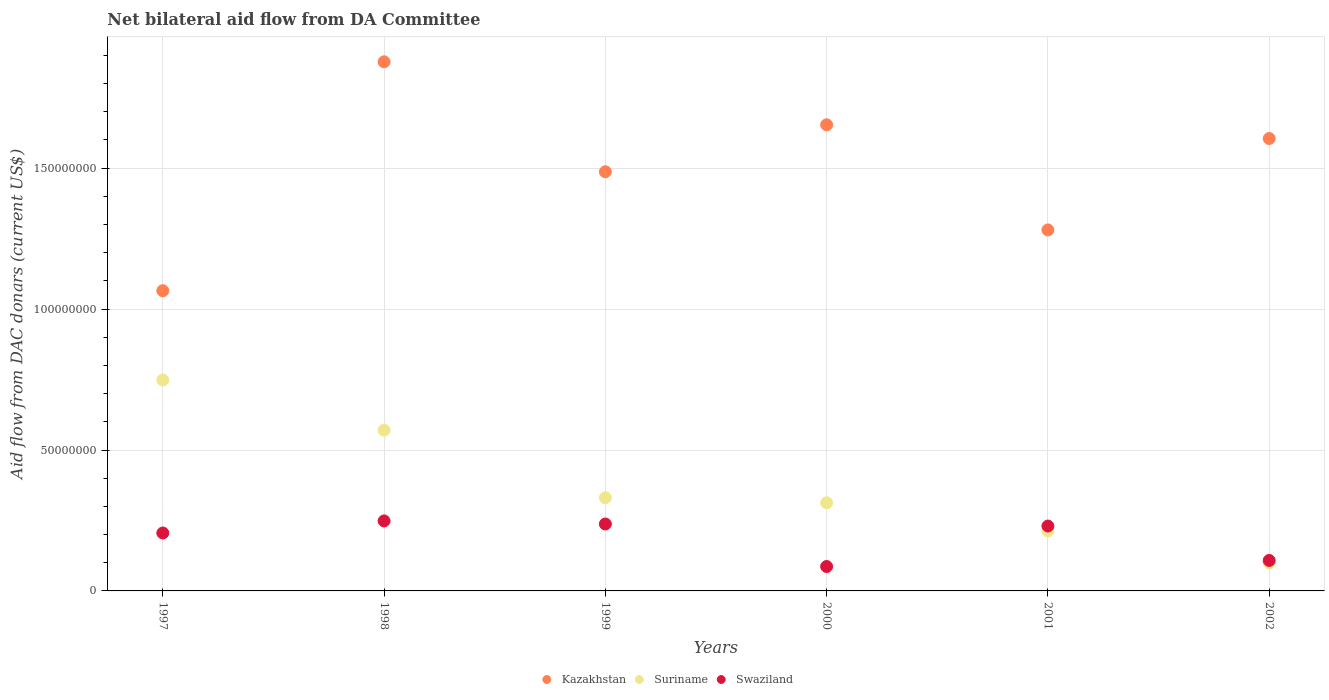How many different coloured dotlines are there?
Offer a terse response. 3. Is the number of dotlines equal to the number of legend labels?
Your answer should be very brief. Yes. What is the aid flow in in Suriname in 2002?
Keep it short and to the point. 9.96e+06. Across all years, what is the maximum aid flow in in Swaziland?
Offer a very short reply. 2.48e+07. Across all years, what is the minimum aid flow in in Swaziland?
Give a very brief answer. 8.66e+06. What is the total aid flow in in Swaziland in the graph?
Provide a short and direct response. 1.12e+08. What is the difference between the aid flow in in Suriname in 1997 and that in 2002?
Keep it short and to the point. 6.49e+07. What is the difference between the aid flow in in Kazakhstan in 1998 and the aid flow in in Suriname in 1999?
Offer a terse response. 1.55e+08. What is the average aid flow in in Suriname per year?
Your answer should be compact. 3.79e+07. In the year 2001, what is the difference between the aid flow in in Swaziland and aid flow in in Kazakhstan?
Keep it short and to the point. -1.05e+08. What is the ratio of the aid flow in in Kazakhstan in 1999 to that in 2000?
Give a very brief answer. 0.9. What is the difference between the highest and the second highest aid flow in in Suriname?
Offer a terse response. 1.78e+07. What is the difference between the highest and the lowest aid flow in in Suriname?
Offer a terse response. 6.49e+07. In how many years, is the aid flow in in Suriname greater than the average aid flow in in Suriname taken over all years?
Make the answer very short. 2. Is it the case that in every year, the sum of the aid flow in in Swaziland and aid flow in in Kazakhstan  is greater than the aid flow in in Suriname?
Keep it short and to the point. Yes. Does the aid flow in in Swaziland monotonically increase over the years?
Ensure brevity in your answer.  No. How many dotlines are there?
Ensure brevity in your answer.  3. Does the graph contain grids?
Your answer should be very brief. Yes. How many legend labels are there?
Provide a short and direct response. 3. How are the legend labels stacked?
Your answer should be very brief. Horizontal. What is the title of the graph?
Provide a short and direct response. Net bilateral aid flow from DA Committee. What is the label or title of the Y-axis?
Provide a succinct answer. Aid flow from DAC donars (current US$). What is the Aid flow from DAC donars (current US$) in Kazakhstan in 1997?
Keep it short and to the point. 1.07e+08. What is the Aid flow from DAC donars (current US$) in Suriname in 1997?
Keep it short and to the point. 7.48e+07. What is the Aid flow from DAC donars (current US$) of Swaziland in 1997?
Your answer should be compact. 2.06e+07. What is the Aid flow from DAC donars (current US$) of Kazakhstan in 1998?
Keep it short and to the point. 1.88e+08. What is the Aid flow from DAC donars (current US$) of Suriname in 1998?
Make the answer very short. 5.70e+07. What is the Aid flow from DAC donars (current US$) of Swaziland in 1998?
Provide a short and direct response. 2.48e+07. What is the Aid flow from DAC donars (current US$) of Kazakhstan in 1999?
Offer a terse response. 1.49e+08. What is the Aid flow from DAC donars (current US$) of Suriname in 1999?
Offer a very short reply. 3.31e+07. What is the Aid flow from DAC donars (current US$) in Swaziland in 1999?
Keep it short and to the point. 2.37e+07. What is the Aid flow from DAC donars (current US$) in Kazakhstan in 2000?
Your answer should be very brief. 1.65e+08. What is the Aid flow from DAC donars (current US$) in Suriname in 2000?
Provide a short and direct response. 3.13e+07. What is the Aid flow from DAC donars (current US$) of Swaziland in 2000?
Make the answer very short. 8.66e+06. What is the Aid flow from DAC donars (current US$) in Kazakhstan in 2001?
Offer a very short reply. 1.28e+08. What is the Aid flow from DAC donars (current US$) in Suriname in 2001?
Keep it short and to the point. 2.13e+07. What is the Aid flow from DAC donars (current US$) in Swaziland in 2001?
Provide a succinct answer. 2.30e+07. What is the Aid flow from DAC donars (current US$) in Kazakhstan in 2002?
Give a very brief answer. 1.61e+08. What is the Aid flow from DAC donars (current US$) in Suriname in 2002?
Make the answer very short. 9.96e+06. What is the Aid flow from DAC donars (current US$) in Swaziland in 2002?
Offer a terse response. 1.08e+07. Across all years, what is the maximum Aid flow from DAC donars (current US$) in Kazakhstan?
Make the answer very short. 1.88e+08. Across all years, what is the maximum Aid flow from DAC donars (current US$) of Suriname?
Keep it short and to the point. 7.48e+07. Across all years, what is the maximum Aid flow from DAC donars (current US$) of Swaziland?
Ensure brevity in your answer.  2.48e+07. Across all years, what is the minimum Aid flow from DAC donars (current US$) of Kazakhstan?
Your answer should be compact. 1.07e+08. Across all years, what is the minimum Aid flow from DAC donars (current US$) of Suriname?
Ensure brevity in your answer.  9.96e+06. Across all years, what is the minimum Aid flow from DAC donars (current US$) of Swaziland?
Provide a succinct answer. 8.66e+06. What is the total Aid flow from DAC donars (current US$) in Kazakhstan in the graph?
Provide a short and direct response. 8.97e+08. What is the total Aid flow from DAC donars (current US$) of Suriname in the graph?
Your response must be concise. 2.28e+08. What is the total Aid flow from DAC donars (current US$) of Swaziland in the graph?
Ensure brevity in your answer.  1.12e+08. What is the difference between the Aid flow from DAC donars (current US$) in Kazakhstan in 1997 and that in 1998?
Offer a very short reply. -8.12e+07. What is the difference between the Aid flow from DAC donars (current US$) in Suriname in 1997 and that in 1998?
Your response must be concise. 1.78e+07. What is the difference between the Aid flow from DAC donars (current US$) of Swaziland in 1997 and that in 1998?
Give a very brief answer. -4.29e+06. What is the difference between the Aid flow from DAC donars (current US$) of Kazakhstan in 1997 and that in 1999?
Provide a short and direct response. -4.22e+07. What is the difference between the Aid flow from DAC donars (current US$) of Suriname in 1997 and that in 1999?
Your answer should be very brief. 4.18e+07. What is the difference between the Aid flow from DAC donars (current US$) of Swaziland in 1997 and that in 1999?
Ensure brevity in your answer.  -3.19e+06. What is the difference between the Aid flow from DAC donars (current US$) of Kazakhstan in 1997 and that in 2000?
Offer a terse response. -5.89e+07. What is the difference between the Aid flow from DAC donars (current US$) in Suriname in 1997 and that in 2000?
Make the answer very short. 4.36e+07. What is the difference between the Aid flow from DAC donars (current US$) in Swaziland in 1997 and that in 2000?
Give a very brief answer. 1.19e+07. What is the difference between the Aid flow from DAC donars (current US$) in Kazakhstan in 1997 and that in 2001?
Give a very brief answer. -2.16e+07. What is the difference between the Aid flow from DAC donars (current US$) in Suriname in 1997 and that in 2001?
Offer a very short reply. 5.36e+07. What is the difference between the Aid flow from DAC donars (current US$) in Swaziland in 1997 and that in 2001?
Ensure brevity in your answer.  -2.47e+06. What is the difference between the Aid flow from DAC donars (current US$) of Kazakhstan in 1997 and that in 2002?
Make the answer very short. -5.40e+07. What is the difference between the Aid flow from DAC donars (current US$) in Suriname in 1997 and that in 2002?
Ensure brevity in your answer.  6.49e+07. What is the difference between the Aid flow from DAC donars (current US$) of Swaziland in 1997 and that in 2002?
Give a very brief answer. 9.74e+06. What is the difference between the Aid flow from DAC donars (current US$) in Kazakhstan in 1998 and that in 1999?
Keep it short and to the point. 3.90e+07. What is the difference between the Aid flow from DAC donars (current US$) of Suriname in 1998 and that in 1999?
Provide a succinct answer. 2.40e+07. What is the difference between the Aid flow from DAC donars (current US$) in Swaziland in 1998 and that in 1999?
Your response must be concise. 1.10e+06. What is the difference between the Aid flow from DAC donars (current US$) in Kazakhstan in 1998 and that in 2000?
Make the answer very short. 2.23e+07. What is the difference between the Aid flow from DAC donars (current US$) in Suriname in 1998 and that in 2000?
Your response must be concise. 2.58e+07. What is the difference between the Aid flow from DAC donars (current US$) of Swaziland in 1998 and that in 2000?
Offer a very short reply. 1.62e+07. What is the difference between the Aid flow from DAC donars (current US$) in Kazakhstan in 1998 and that in 2001?
Provide a short and direct response. 5.96e+07. What is the difference between the Aid flow from DAC donars (current US$) in Suriname in 1998 and that in 2001?
Provide a succinct answer. 3.58e+07. What is the difference between the Aid flow from DAC donars (current US$) of Swaziland in 1998 and that in 2001?
Your answer should be compact. 1.82e+06. What is the difference between the Aid flow from DAC donars (current US$) in Kazakhstan in 1998 and that in 2002?
Ensure brevity in your answer.  2.72e+07. What is the difference between the Aid flow from DAC donars (current US$) in Suriname in 1998 and that in 2002?
Provide a succinct answer. 4.71e+07. What is the difference between the Aid flow from DAC donars (current US$) in Swaziland in 1998 and that in 2002?
Provide a succinct answer. 1.40e+07. What is the difference between the Aid flow from DAC donars (current US$) in Kazakhstan in 1999 and that in 2000?
Your answer should be very brief. -1.67e+07. What is the difference between the Aid flow from DAC donars (current US$) in Suriname in 1999 and that in 2000?
Ensure brevity in your answer.  1.77e+06. What is the difference between the Aid flow from DAC donars (current US$) of Swaziland in 1999 and that in 2000?
Offer a terse response. 1.51e+07. What is the difference between the Aid flow from DAC donars (current US$) of Kazakhstan in 1999 and that in 2001?
Keep it short and to the point. 2.06e+07. What is the difference between the Aid flow from DAC donars (current US$) in Suriname in 1999 and that in 2001?
Offer a very short reply. 1.18e+07. What is the difference between the Aid flow from DAC donars (current US$) of Swaziland in 1999 and that in 2001?
Keep it short and to the point. 7.20e+05. What is the difference between the Aid flow from DAC donars (current US$) in Kazakhstan in 1999 and that in 2002?
Ensure brevity in your answer.  -1.18e+07. What is the difference between the Aid flow from DAC donars (current US$) in Suriname in 1999 and that in 2002?
Give a very brief answer. 2.31e+07. What is the difference between the Aid flow from DAC donars (current US$) of Swaziland in 1999 and that in 2002?
Your response must be concise. 1.29e+07. What is the difference between the Aid flow from DAC donars (current US$) of Kazakhstan in 2000 and that in 2001?
Ensure brevity in your answer.  3.73e+07. What is the difference between the Aid flow from DAC donars (current US$) in Swaziland in 2000 and that in 2001?
Keep it short and to the point. -1.44e+07. What is the difference between the Aid flow from DAC donars (current US$) of Kazakhstan in 2000 and that in 2002?
Offer a terse response. 4.88e+06. What is the difference between the Aid flow from DAC donars (current US$) in Suriname in 2000 and that in 2002?
Give a very brief answer. 2.13e+07. What is the difference between the Aid flow from DAC donars (current US$) of Swaziland in 2000 and that in 2002?
Provide a succinct answer. -2.15e+06. What is the difference between the Aid flow from DAC donars (current US$) in Kazakhstan in 2001 and that in 2002?
Provide a succinct answer. -3.24e+07. What is the difference between the Aid flow from DAC donars (current US$) in Suriname in 2001 and that in 2002?
Your answer should be very brief. 1.13e+07. What is the difference between the Aid flow from DAC donars (current US$) of Swaziland in 2001 and that in 2002?
Your answer should be compact. 1.22e+07. What is the difference between the Aid flow from DAC donars (current US$) in Kazakhstan in 1997 and the Aid flow from DAC donars (current US$) in Suriname in 1998?
Your answer should be compact. 4.95e+07. What is the difference between the Aid flow from DAC donars (current US$) of Kazakhstan in 1997 and the Aid flow from DAC donars (current US$) of Swaziland in 1998?
Offer a terse response. 8.17e+07. What is the difference between the Aid flow from DAC donars (current US$) in Suriname in 1997 and the Aid flow from DAC donars (current US$) in Swaziland in 1998?
Keep it short and to the point. 5.00e+07. What is the difference between the Aid flow from DAC donars (current US$) of Kazakhstan in 1997 and the Aid flow from DAC donars (current US$) of Suriname in 1999?
Provide a short and direct response. 7.35e+07. What is the difference between the Aid flow from DAC donars (current US$) of Kazakhstan in 1997 and the Aid flow from DAC donars (current US$) of Swaziland in 1999?
Offer a very short reply. 8.28e+07. What is the difference between the Aid flow from DAC donars (current US$) of Suriname in 1997 and the Aid flow from DAC donars (current US$) of Swaziland in 1999?
Ensure brevity in your answer.  5.11e+07. What is the difference between the Aid flow from DAC donars (current US$) in Kazakhstan in 1997 and the Aid flow from DAC donars (current US$) in Suriname in 2000?
Your answer should be very brief. 7.52e+07. What is the difference between the Aid flow from DAC donars (current US$) in Kazakhstan in 1997 and the Aid flow from DAC donars (current US$) in Swaziland in 2000?
Offer a very short reply. 9.79e+07. What is the difference between the Aid flow from DAC donars (current US$) of Suriname in 1997 and the Aid flow from DAC donars (current US$) of Swaziland in 2000?
Ensure brevity in your answer.  6.62e+07. What is the difference between the Aid flow from DAC donars (current US$) of Kazakhstan in 1997 and the Aid flow from DAC donars (current US$) of Suriname in 2001?
Ensure brevity in your answer.  8.52e+07. What is the difference between the Aid flow from DAC donars (current US$) in Kazakhstan in 1997 and the Aid flow from DAC donars (current US$) in Swaziland in 2001?
Make the answer very short. 8.35e+07. What is the difference between the Aid flow from DAC donars (current US$) of Suriname in 1997 and the Aid flow from DAC donars (current US$) of Swaziland in 2001?
Offer a terse response. 5.18e+07. What is the difference between the Aid flow from DAC donars (current US$) in Kazakhstan in 1997 and the Aid flow from DAC donars (current US$) in Suriname in 2002?
Give a very brief answer. 9.66e+07. What is the difference between the Aid flow from DAC donars (current US$) in Kazakhstan in 1997 and the Aid flow from DAC donars (current US$) in Swaziland in 2002?
Your answer should be very brief. 9.57e+07. What is the difference between the Aid flow from DAC donars (current US$) of Suriname in 1997 and the Aid flow from DAC donars (current US$) of Swaziland in 2002?
Make the answer very short. 6.40e+07. What is the difference between the Aid flow from DAC donars (current US$) in Kazakhstan in 1998 and the Aid flow from DAC donars (current US$) in Suriname in 1999?
Keep it short and to the point. 1.55e+08. What is the difference between the Aid flow from DAC donars (current US$) in Kazakhstan in 1998 and the Aid flow from DAC donars (current US$) in Swaziland in 1999?
Your answer should be compact. 1.64e+08. What is the difference between the Aid flow from DAC donars (current US$) of Suriname in 1998 and the Aid flow from DAC donars (current US$) of Swaziland in 1999?
Provide a succinct answer. 3.33e+07. What is the difference between the Aid flow from DAC donars (current US$) of Kazakhstan in 1998 and the Aid flow from DAC donars (current US$) of Suriname in 2000?
Give a very brief answer. 1.56e+08. What is the difference between the Aid flow from DAC donars (current US$) in Kazakhstan in 1998 and the Aid flow from DAC donars (current US$) in Swaziland in 2000?
Your response must be concise. 1.79e+08. What is the difference between the Aid flow from DAC donars (current US$) in Suriname in 1998 and the Aid flow from DAC donars (current US$) in Swaziland in 2000?
Offer a very short reply. 4.84e+07. What is the difference between the Aid flow from DAC donars (current US$) of Kazakhstan in 1998 and the Aid flow from DAC donars (current US$) of Suriname in 2001?
Keep it short and to the point. 1.66e+08. What is the difference between the Aid flow from DAC donars (current US$) in Kazakhstan in 1998 and the Aid flow from DAC donars (current US$) in Swaziland in 2001?
Your response must be concise. 1.65e+08. What is the difference between the Aid flow from DAC donars (current US$) of Suriname in 1998 and the Aid flow from DAC donars (current US$) of Swaziland in 2001?
Provide a short and direct response. 3.40e+07. What is the difference between the Aid flow from DAC donars (current US$) of Kazakhstan in 1998 and the Aid flow from DAC donars (current US$) of Suriname in 2002?
Your answer should be very brief. 1.78e+08. What is the difference between the Aid flow from DAC donars (current US$) in Kazakhstan in 1998 and the Aid flow from DAC donars (current US$) in Swaziland in 2002?
Give a very brief answer. 1.77e+08. What is the difference between the Aid flow from DAC donars (current US$) of Suriname in 1998 and the Aid flow from DAC donars (current US$) of Swaziland in 2002?
Provide a short and direct response. 4.62e+07. What is the difference between the Aid flow from DAC donars (current US$) in Kazakhstan in 1999 and the Aid flow from DAC donars (current US$) in Suriname in 2000?
Keep it short and to the point. 1.17e+08. What is the difference between the Aid flow from DAC donars (current US$) of Kazakhstan in 1999 and the Aid flow from DAC donars (current US$) of Swaziland in 2000?
Provide a short and direct response. 1.40e+08. What is the difference between the Aid flow from DAC donars (current US$) of Suriname in 1999 and the Aid flow from DAC donars (current US$) of Swaziland in 2000?
Your answer should be very brief. 2.44e+07. What is the difference between the Aid flow from DAC donars (current US$) in Kazakhstan in 1999 and the Aid flow from DAC donars (current US$) in Suriname in 2001?
Your answer should be very brief. 1.27e+08. What is the difference between the Aid flow from DAC donars (current US$) of Kazakhstan in 1999 and the Aid flow from DAC donars (current US$) of Swaziland in 2001?
Your answer should be very brief. 1.26e+08. What is the difference between the Aid flow from DAC donars (current US$) in Suriname in 1999 and the Aid flow from DAC donars (current US$) in Swaziland in 2001?
Offer a terse response. 1.00e+07. What is the difference between the Aid flow from DAC donars (current US$) of Kazakhstan in 1999 and the Aid flow from DAC donars (current US$) of Suriname in 2002?
Offer a terse response. 1.39e+08. What is the difference between the Aid flow from DAC donars (current US$) of Kazakhstan in 1999 and the Aid flow from DAC donars (current US$) of Swaziland in 2002?
Give a very brief answer. 1.38e+08. What is the difference between the Aid flow from DAC donars (current US$) in Suriname in 1999 and the Aid flow from DAC donars (current US$) in Swaziland in 2002?
Your answer should be compact. 2.22e+07. What is the difference between the Aid flow from DAC donars (current US$) of Kazakhstan in 2000 and the Aid flow from DAC donars (current US$) of Suriname in 2001?
Your answer should be compact. 1.44e+08. What is the difference between the Aid flow from DAC donars (current US$) in Kazakhstan in 2000 and the Aid flow from DAC donars (current US$) in Swaziland in 2001?
Your response must be concise. 1.42e+08. What is the difference between the Aid flow from DAC donars (current US$) in Suriname in 2000 and the Aid flow from DAC donars (current US$) in Swaziland in 2001?
Your response must be concise. 8.27e+06. What is the difference between the Aid flow from DAC donars (current US$) of Kazakhstan in 2000 and the Aid flow from DAC donars (current US$) of Suriname in 2002?
Your answer should be compact. 1.55e+08. What is the difference between the Aid flow from DAC donars (current US$) of Kazakhstan in 2000 and the Aid flow from DAC donars (current US$) of Swaziland in 2002?
Your response must be concise. 1.55e+08. What is the difference between the Aid flow from DAC donars (current US$) in Suriname in 2000 and the Aid flow from DAC donars (current US$) in Swaziland in 2002?
Make the answer very short. 2.05e+07. What is the difference between the Aid flow from DAC donars (current US$) in Kazakhstan in 2001 and the Aid flow from DAC donars (current US$) in Suriname in 2002?
Provide a short and direct response. 1.18e+08. What is the difference between the Aid flow from DAC donars (current US$) in Kazakhstan in 2001 and the Aid flow from DAC donars (current US$) in Swaziland in 2002?
Provide a succinct answer. 1.17e+08. What is the difference between the Aid flow from DAC donars (current US$) of Suriname in 2001 and the Aid flow from DAC donars (current US$) of Swaziland in 2002?
Ensure brevity in your answer.  1.05e+07. What is the average Aid flow from DAC donars (current US$) in Kazakhstan per year?
Give a very brief answer. 1.50e+08. What is the average Aid flow from DAC donars (current US$) of Suriname per year?
Make the answer very short. 3.79e+07. What is the average Aid flow from DAC donars (current US$) of Swaziland per year?
Ensure brevity in your answer.  1.86e+07. In the year 1997, what is the difference between the Aid flow from DAC donars (current US$) in Kazakhstan and Aid flow from DAC donars (current US$) in Suriname?
Your response must be concise. 3.17e+07. In the year 1997, what is the difference between the Aid flow from DAC donars (current US$) of Kazakhstan and Aid flow from DAC donars (current US$) of Swaziland?
Your response must be concise. 8.60e+07. In the year 1997, what is the difference between the Aid flow from DAC donars (current US$) of Suriname and Aid flow from DAC donars (current US$) of Swaziland?
Give a very brief answer. 5.43e+07. In the year 1998, what is the difference between the Aid flow from DAC donars (current US$) of Kazakhstan and Aid flow from DAC donars (current US$) of Suriname?
Your answer should be compact. 1.31e+08. In the year 1998, what is the difference between the Aid flow from DAC donars (current US$) of Kazakhstan and Aid flow from DAC donars (current US$) of Swaziland?
Give a very brief answer. 1.63e+08. In the year 1998, what is the difference between the Aid flow from DAC donars (current US$) in Suriname and Aid flow from DAC donars (current US$) in Swaziland?
Keep it short and to the point. 3.22e+07. In the year 1999, what is the difference between the Aid flow from DAC donars (current US$) of Kazakhstan and Aid flow from DAC donars (current US$) of Suriname?
Make the answer very short. 1.16e+08. In the year 1999, what is the difference between the Aid flow from DAC donars (current US$) in Kazakhstan and Aid flow from DAC donars (current US$) in Swaziland?
Provide a short and direct response. 1.25e+08. In the year 1999, what is the difference between the Aid flow from DAC donars (current US$) of Suriname and Aid flow from DAC donars (current US$) of Swaziland?
Give a very brief answer. 9.32e+06. In the year 2000, what is the difference between the Aid flow from DAC donars (current US$) of Kazakhstan and Aid flow from DAC donars (current US$) of Suriname?
Your response must be concise. 1.34e+08. In the year 2000, what is the difference between the Aid flow from DAC donars (current US$) of Kazakhstan and Aid flow from DAC donars (current US$) of Swaziland?
Offer a terse response. 1.57e+08. In the year 2000, what is the difference between the Aid flow from DAC donars (current US$) of Suriname and Aid flow from DAC donars (current US$) of Swaziland?
Your answer should be compact. 2.26e+07. In the year 2001, what is the difference between the Aid flow from DAC donars (current US$) in Kazakhstan and Aid flow from DAC donars (current US$) in Suriname?
Ensure brevity in your answer.  1.07e+08. In the year 2001, what is the difference between the Aid flow from DAC donars (current US$) of Kazakhstan and Aid flow from DAC donars (current US$) of Swaziland?
Make the answer very short. 1.05e+08. In the year 2001, what is the difference between the Aid flow from DAC donars (current US$) in Suriname and Aid flow from DAC donars (current US$) in Swaziland?
Your answer should be very brief. -1.73e+06. In the year 2002, what is the difference between the Aid flow from DAC donars (current US$) of Kazakhstan and Aid flow from DAC donars (current US$) of Suriname?
Offer a very short reply. 1.51e+08. In the year 2002, what is the difference between the Aid flow from DAC donars (current US$) of Kazakhstan and Aid flow from DAC donars (current US$) of Swaziland?
Offer a terse response. 1.50e+08. In the year 2002, what is the difference between the Aid flow from DAC donars (current US$) of Suriname and Aid flow from DAC donars (current US$) of Swaziland?
Your answer should be very brief. -8.50e+05. What is the ratio of the Aid flow from DAC donars (current US$) in Kazakhstan in 1997 to that in 1998?
Make the answer very short. 0.57. What is the ratio of the Aid flow from DAC donars (current US$) of Suriname in 1997 to that in 1998?
Ensure brevity in your answer.  1.31. What is the ratio of the Aid flow from DAC donars (current US$) of Swaziland in 1997 to that in 1998?
Ensure brevity in your answer.  0.83. What is the ratio of the Aid flow from DAC donars (current US$) of Kazakhstan in 1997 to that in 1999?
Give a very brief answer. 0.72. What is the ratio of the Aid flow from DAC donars (current US$) in Suriname in 1997 to that in 1999?
Your response must be concise. 2.26. What is the ratio of the Aid flow from DAC donars (current US$) in Swaziland in 1997 to that in 1999?
Ensure brevity in your answer.  0.87. What is the ratio of the Aid flow from DAC donars (current US$) of Kazakhstan in 1997 to that in 2000?
Offer a very short reply. 0.64. What is the ratio of the Aid flow from DAC donars (current US$) in Suriname in 1997 to that in 2000?
Your answer should be very brief. 2.39. What is the ratio of the Aid flow from DAC donars (current US$) of Swaziland in 1997 to that in 2000?
Provide a succinct answer. 2.37. What is the ratio of the Aid flow from DAC donars (current US$) of Kazakhstan in 1997 to that in 2001?
Your response must be concise. 0.83. What is the ratio of the Aid flow from DAC donars (current US$) of Suriname in 1997 to that in 2001?
Keep it short and to the point. 3.52. What is the ratio of the Aid flow from DAC donars (current US$) in Swaziland in 1997 to that in 2001?
Provide a succinct answer. 0.89. What is the ratio of the Aid flow from DAC donars (current US$) in Kazakhstan in 1997 to that in 2002?
Your response must be concise. 0.66. What is the ratio of the Aid flow from DAC donars (current US$) in Suriname in 1997 to that in 2002?
Offer a very short reply. 7.52. What is the ratio of the Aid flow from DAC donars (current US$) of Swaziland in 1997 to that in 2002?
Your response must be concise. 1.9. What is the ratio of the Aid flow from DAC donars (current US$) in Kazakhstan in 1998 to that in 1999?
Make the answer very short. 1.26. What is the ratio of the Aid flow from DAC donars (current US$) of Suriname in 1998 to that in 1999?
Your answer should be very brief. 1.73. What is the ratio of the Aid flow from DAC donars (current US$) in Swaziland in 1998 to that in 1999?
Make the answer very short. 1.05. What is the ratio of the Aid flow from DAC donars (current US$) of Kazakhstan in 1998 to that in 2000?
Your answer should be very brief. 1.14. What is the ratio of the Aid flow from DAC donars (current US$) of Suriname in 1998 to that in 2000?
Give a very brief answer. 1.82. What is the ratio of the Aid flow from DAC donars (current US$) of Swaziland in 1998 to that in 2000?
Provide a succinct answer. 2.87. What is the ratio of the Aid flow from DAC donars (current US$) in Kazakhstan in 1998 to that in 2001?
Offer a terse response. 1.47. What is the ratio of the Aid flow from DAC donars (current US$) in Suriname in 1998 to that in 2001?
Your response must be concise. 2.68. What is the ratio of the Aid flow from DAC donars (current US$) of Swaziland in 1998 to that in 2001?
Offer a terse response. 1.08. What is the ratio of the Aid flow from DAC donars (current US$) of Kazakhstan in 1998 to that in 2002?
Ensure brevity in your answer.  1.17. What is the ratio of the Aid flow from DAC donars (current US$) in Suriname in 1998 to that in 2002?
Offer a terse response. 5.73. What is the ratio of the Aid flow from DAC donars (current US$) of Swaziland in 1998 to that in 2002?
Ensure brevity in your answer.  2.3. What is the ratio of the Aid flow from DAC donars (current US$) of Kazakhstan in 1999 to that in 2000?
Offer a terse response. 0.9. What is the ratio of the Aid flow from DAC donars (current US$) of Suriname in 1999 to that in 2000?
Make the answer very short. 1.06. What is the ratio of the Aid flow from DAC donars (current US$) in Swaziland in 1999 to that in 2000?
Ensure brevity in your answer.  2.74. What is the ratio of the Aid flow from DAC donars (current US$) of Kazakhstan in 1999 to that in 2001?
Keep it short and to the point. 1.16. What is the ratio of the Aid flow from DAC donars (current US$) of Suriname in 1999 to that in 2001?
Provide a short and direct response. 1.55. What is the ratio of the Aid flow from DAC donars (current US$) in Swaziland in 1999 to that in 2001?
Give a very brief answer. 1.03. What is the ratio of the Aid flow from DAC donars (current US$) in Kazakhstan in 1999 to that in 2002?
Give a very brief answer. 0.93. What is the ratio of the Aid flow from DAC donars (current US$) in Suriname in 1999 to that in 2002?
Provide a succinct answer. 3.32. What is the ratio of the Aid flow from DAC donars (current US$) of Swaziland in 1999 to that in 2002?
Provide a succinct answer. 2.2. What is the ratio of the Aid flow from DAC donars (current US$) in Kazakhstan in 2000 to that in 2001?
Keep it short and to the point. 1.29. What is the ratio of the Aid flow from DAC donars (current US$) in Suriname in 2000 to that in 2001?
Provide a short and direct response. 1.47. What is the ratio of the Aid flow from DAC donars (current US$) in Swaziland in 2000 to that in 2001?
Provide a short and direct response. 0.38. What is the ratio of the Aid flow from DAC donars (current US$) of Kazakhstan in 2000 to that in 2002?
Your answer should be very brief. 1.03. What is the ratio of the Aid flow from DAC donars (current US$) of Suriname in 2000 to that in 2002?
Give a very brief answer. 3.14. What is the ratio of the Aid flow from DAC donars (current US$) of Swaziland in 2000 to that in 2002?
Provide a short and direct response. 0.8. What is the ratio of the Aid flow from DAC donars (current US$) in Kazakhstan in 2001 to that in 2002?
Your response must be concise. 0.8. What is the ratio of the Aid flow from DAC donars (current US$) of Suriname in 2001 to that in 2002?
Offer a very short reply. 2.14. What is the ratio of the Aid flow from DAC donars (current US$) of Swaziland in 2001 to that in 2002?
Your response must be concise. 2.13. What is the difference between the highest and the second highest Aid flow from DAC donars (current US$) of Kazakhstan?
Provide a short and direct response. 2.23e+07. What is the difference between the highest and the second highest Aid flow from DAC donars (current US$) of Suriname?
Keep it short and to the point. 1.78e+07. What is the difference between the highest and the second highest Aid flow from DAC donars (current US$) in Swaziland?
Make the answer very short. 1.10e+06. What is the difference between the highest and the lowest Aid flow from DAC donars (current US$) in Kazakhstan?
Make the answer very short. 8.12e+07. What is the difference between the highest and the lowest Aid flow from DAC donars (current US$) in Suriname?
Your answer should be very brief. 6.49e+07. What is the difference between the highest and the lowest Aid flow from DAC donars (current US$) of Swaziland?
Offer a terse response. 1.62e+07. 